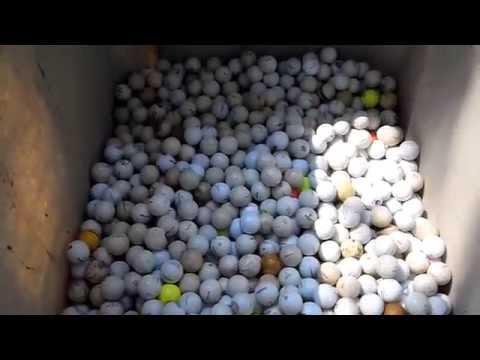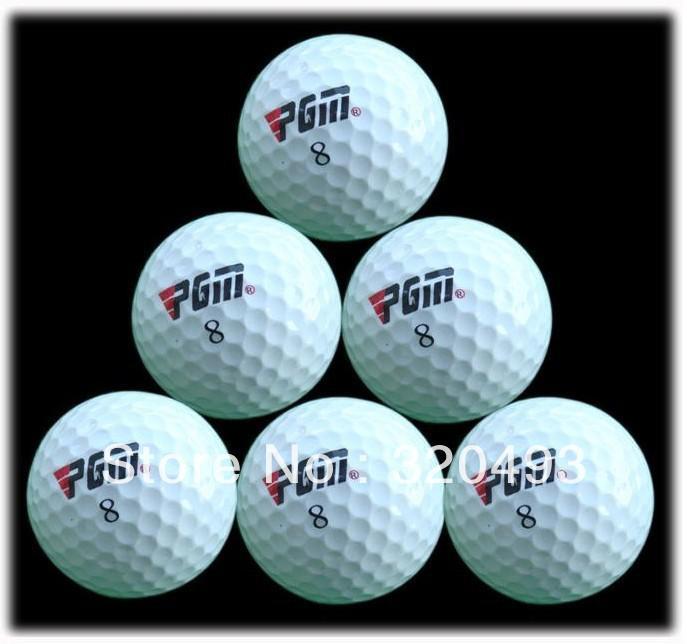The first image is the image on the left, the second image is the image on the right. Assess this claim about the two images: "Exactly four balls are posed close together in one image, and all balls have the same surface color.". Correct or not? Answer yes or no. No. The first image is the image on the left, the second image is the image on the right. Evaluate the accuracy of this statement regarding the images: "At least one of the images feature a six golf balls arranged in a shape.". Is it true? Answer yes or no. Yes. 